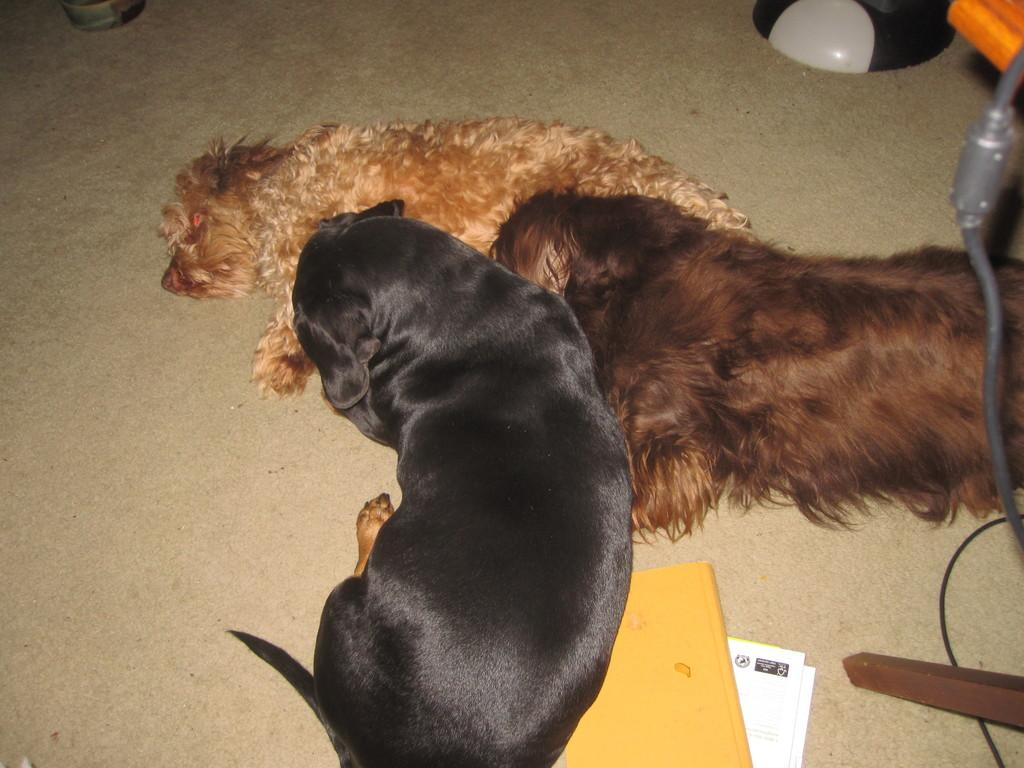How many dogs are present in the image? There are three dogs in the image. Where are the dogs located? The dogs are on the floor. What else can be seen near the dogs? There are papers near the dogs. Can you describe the black and white object in the image? There is a black and white object in the image, but its specific details are not mentioned in the facts. What is on the right side of the image? There is a wire on the right side of the image. How many rabbits are hopping around the dogs in the image? There are no rabbits present in the image; it only features three dogs. What type of sack can be seen in the image? There is no sack present in the image. 